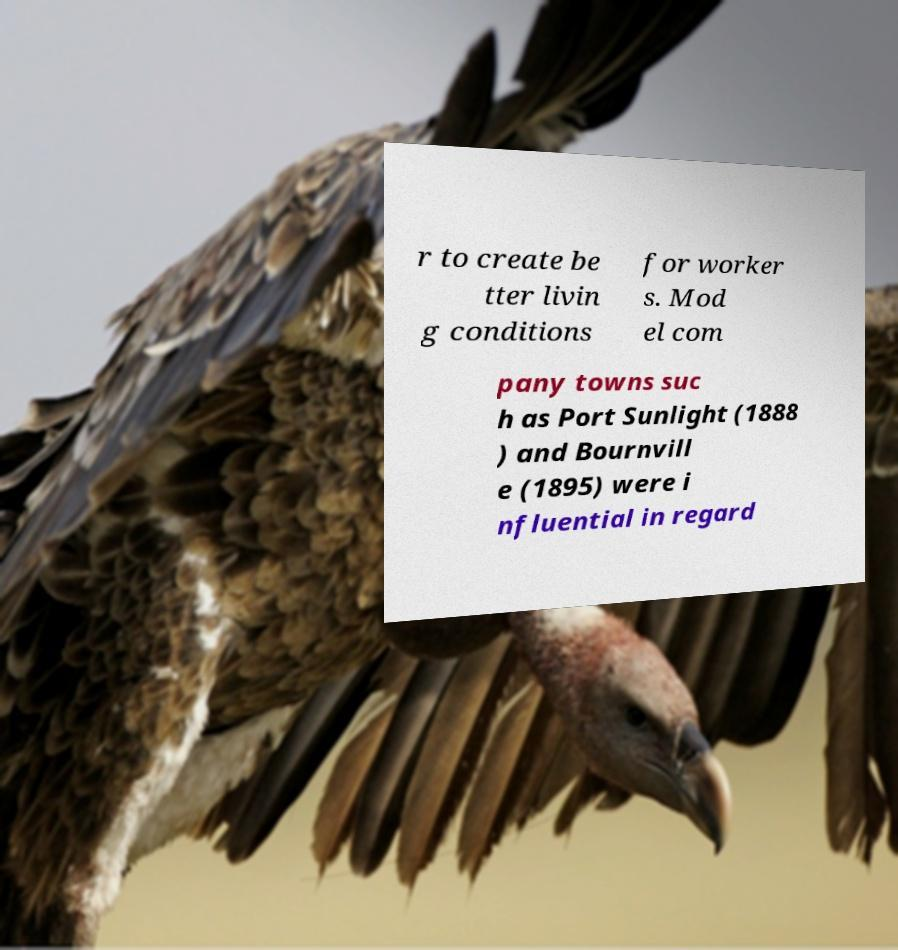I need the written content from this picture converted into text. Can you do that? r to create be tter livin g conditions for worker s. Mod el com pany towns suc h as Port Sunlight (1888 ) and Bournvill e (1895) were i nfluential in regard 